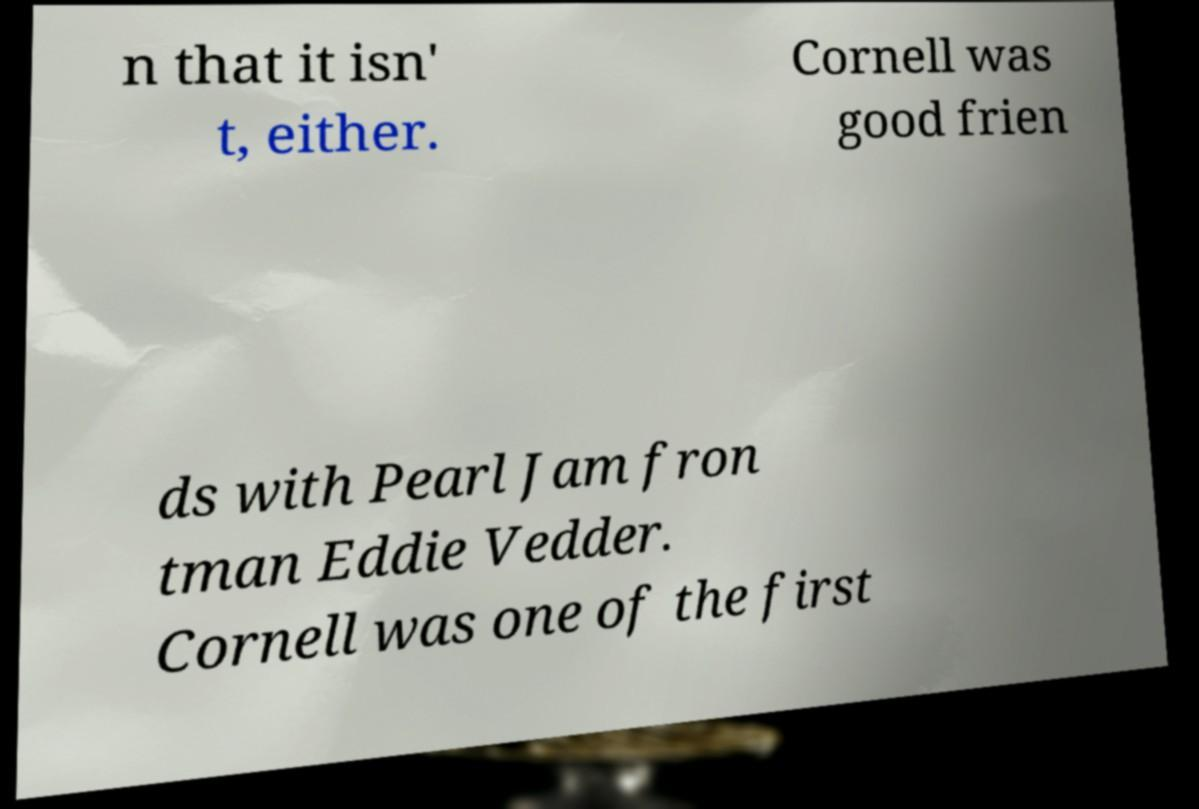What messages or text are displayed in this image? I need them in a readable, typed format. n that it isn' t, either. Cornell was good frien ds with Pearl Jam fron tman Eddie Vedder. Cornell was one of the first 